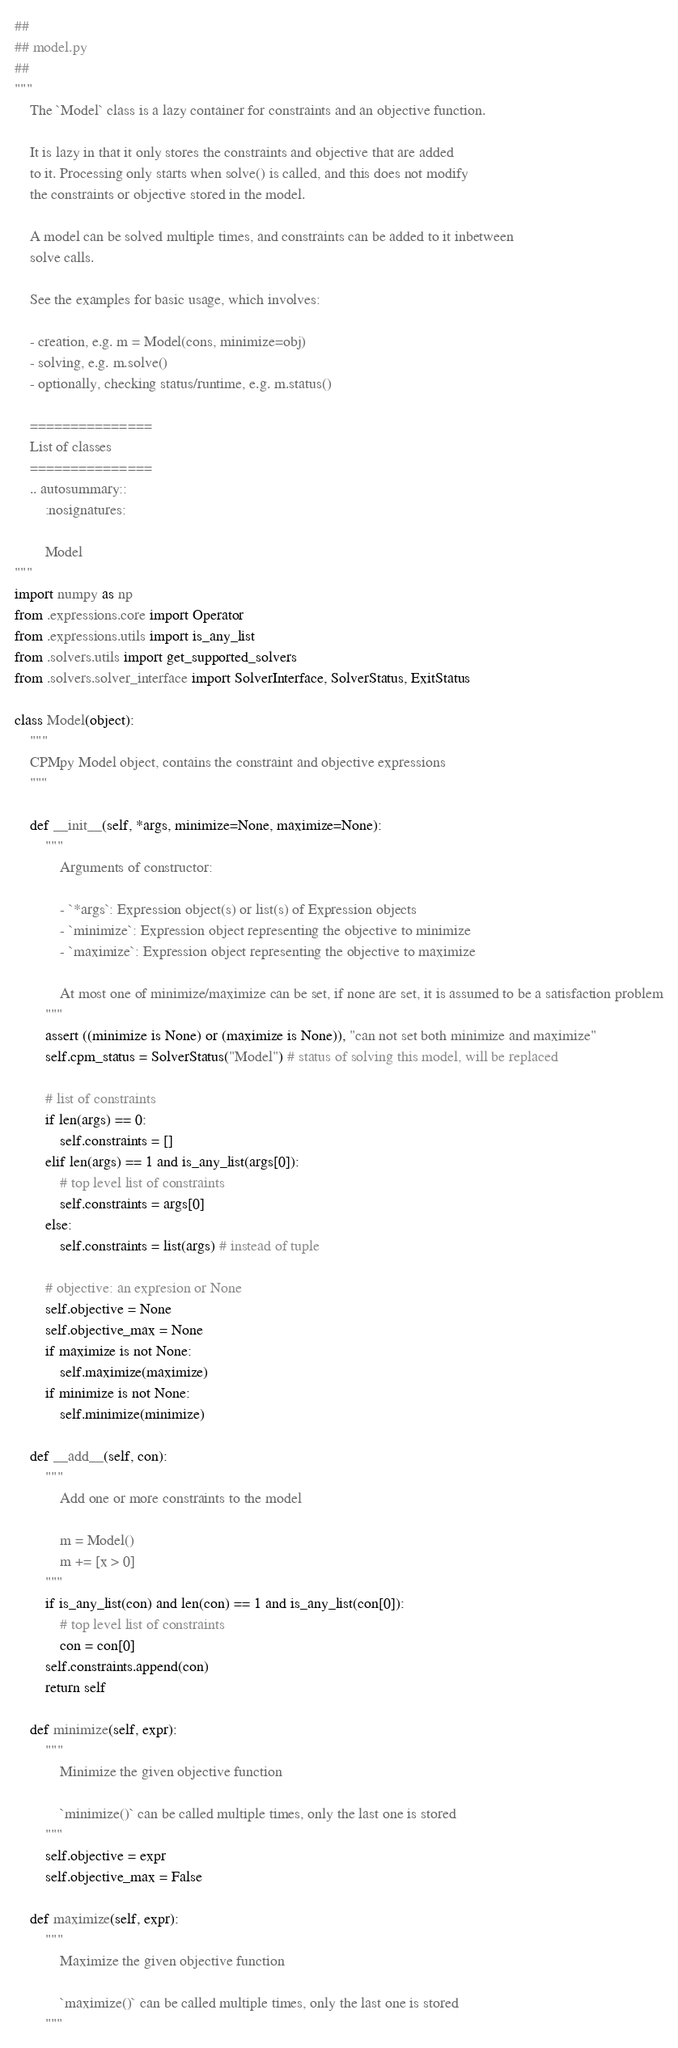<code> <loc_0><loc_0><loc_500><loc_500><_Python_>##
## model.py
##
"""
    The `Model` class is a lazy container for constraints and an objective function.

    It is lazy in that it only stores the constraints and objective that are added
    to it. Processing only starts when solve() is called, and this does not modify
    the constraints or objective stored in the model.

    A model can be solved multiple times, and constraints can be added to it inbetween
    solve calls.

    See the examples for basic usage, which involves:

    - creation, e.g. m = Model(cons, minimize=obj)
    - solving, e.g. m.solve()
    - optionally, checking status/runtime, e.g. m.status()

    ===============
    List of classes
    ===============
    .. autosummary::
        :nosignatures:

        Model
"""
import numpy as np
from .expressions.core import Operator
from .expressions.utils import is_any_list
from .solvers.utils import get_supported_solvers
from .solvers.solver_interface import SolverInterface, SolverStatus, ExitStatus

class Model(object):
    """
    CPMpy Model object, contains the constraint and objective expressions
    """

    def __init__(self, *args, minimize=None, maximize=None):
        """
            Arguments of constructor:

            - `*args`: Expression object(s) or list(s) of Expression objects
            - `minimize`: Expression object representing the objective to minimize
            - `maximize`: Expression object representing the objective to maximize

            At most one of minimize/maximize can be set, if none are set, it is assumed to be a satisfaction problem
        """
        assert ((minimize is None) or (maximize is None)), "can not set both minimize and maximize"
        self.cpm_status = SolverStatus("Model") # status of solving this model, will be replaced

        # list of constraints
        if len(args) == 0:
            self.constraints = []
        elif len(args) == 1 and is_any_list(args[0]):
            # top level list of constraints
            self.constraints = args[0]
        else:
            self.constraints = list(args) # instead of tuple

        # objective: an expresion or None
        self.objective = None
        self.objective_max = None
        if maximize is not None:
            self.maximize(maximize)
        if minimize is not None:
            self.minimize(minimize)
        
    def __add__(self, con):
        """
            Add one or more constraints to the model

            m = Model()
            m += [x > 0]
        """
        if is_any_list(con) and len(con) == 1 and is_any_list(con[0]):
            # top level list of constraints
            con = con[0]
        self.constraints.append(con)
        return self

    def minimize(self, expr):
        """
            Minimize the given objective function

            `minimize()` can be called multiple times, only the last one is stored
        """
        self.objective = expr
        self.objective_max = False

    def maximize(self, expr):
        """
            Maximize the given objective function

            `maximize()` can be called multiple times, only the last one is stored
        """</code> 